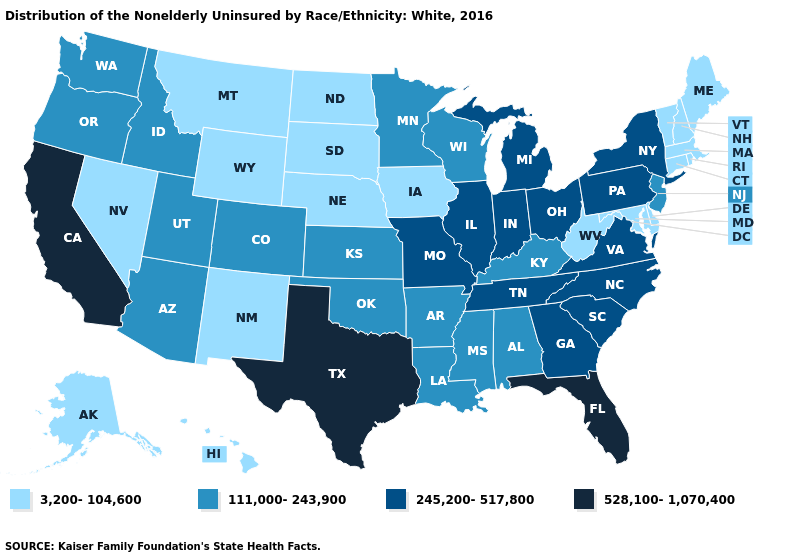Among the states that border Georgia , which have the lowest value?
Give a very brief answer. Alabama. What is the value of Arizona?
Concise answer only. 111,000-243,900. Which states have the lowest value in the USA?
Quick response, please. Alaska, Connecticut, Delaware, Hawaii, Iowa, Maine, Maryland, Massachusetts, Montana, Nebraska, Nevada, New Hampshire, New Mexico, North Dakota, Rhode Island, South Dakota, Vermont, West Virginia, Wyoming. Name the states that have a value in the range 245,200-517,800?
Concise answer only. Georgia, Illinois, Indiana, Michigan, Missouri, New York, North Carolina, Ohio, Pennsylvania, South Carolina, Tennessee, Virginia. What is the value of Hawaii?
Answer briefly. 3,200-104,600. What is the lowest value in the USA?
Quick response, please. 3,200-104,600. Among the states that border Virginia , which have the lowest value?
Keep it brief. Maryland, West Virginia. Name the states that have a value in the range 245,200-517,800?
Quick response, please. Georgia, Illinois, Indiana, Michigan, Missouri, New York, North Carolina, Ohio, Pennsylvania, South Carolina, Tennessee, Virginia. Does Indiana have the highest value in the MidWest?
Concise answer only. Yes. Name the states that have a value in the range 111,000-243,900?
Write a very short answer. Alabama, Arizona, Arkansas, Colorado, Idaho, Kansas, Kentucky, Louisiana, Minnesota, Mississippi, New Jersey, Oklahoma, Oregon, Utah, Washington, Wisconsin. What is the value of Washington?
Answer briefly. 111,000-243,900. Does Minnesota have the same value as Wisconsin?
Be succinct. Yes. Name the states that have a value in the range 245,200-517,800?
Concise answer only. Georgia, Illinois, Indiana, Michigan, Missouri, New York, North Carolina, Ohio, Pennsylvania, South Carolina, Tennessee, Virginia. What is the value of Alabama?
Concise answer only. 111,000-243,900. What is the lowest value in the USA?
Keep it brief. 3,200-104,600. 